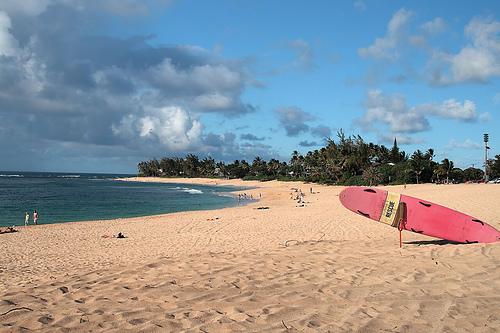Is there a storm coming in from the west?
Write a very short answer. Yes. What color is the water?
Be succinct. Blue. What do you call the land structure in the background?
Short answer required. Beach. What is the man doing?
Be succinct. Walking. Are these sands, as depicted here, a sort of terra cotta color?
Short answer required. Yes. Is there a litter bin close by?
Be succinct. No. Is there a kite in the water?
Keep it brief. No. 